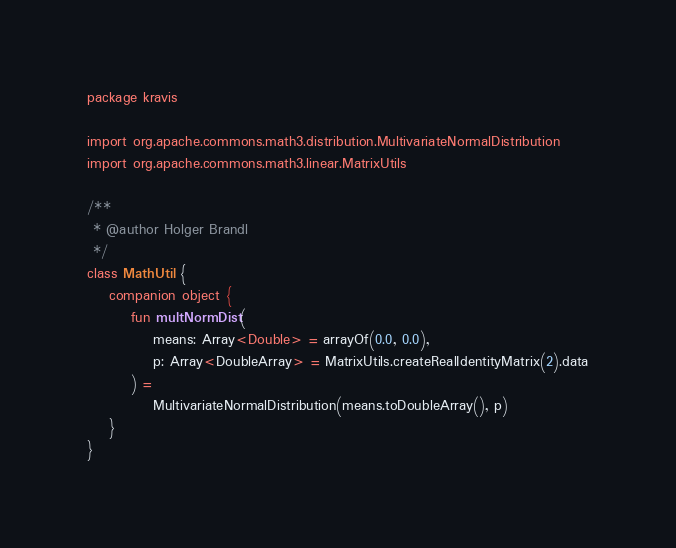Convert code to text. <code><loc_0><loc_0><loc_500><loc_500><_Kotlin_>package kravis

import org.apache.commons.math3.distribution.MultivariateNormalDistribution
import org.apache.commons.math3.linear.MatrixUtils

/**
 * @author Holger Brandl
 */
class MathUtil {
    companion object {
        fun multNormDist(
            means: Array<Double> = arrayOf(0.0, 0.0),
            p: Array<DoubleArray> = MatrixUtils.createRealIdentityMatrix(2).data
        ) =
            MultivariateNormalDistribution(means.toDoubleArray(), p)
    }
}</code> 